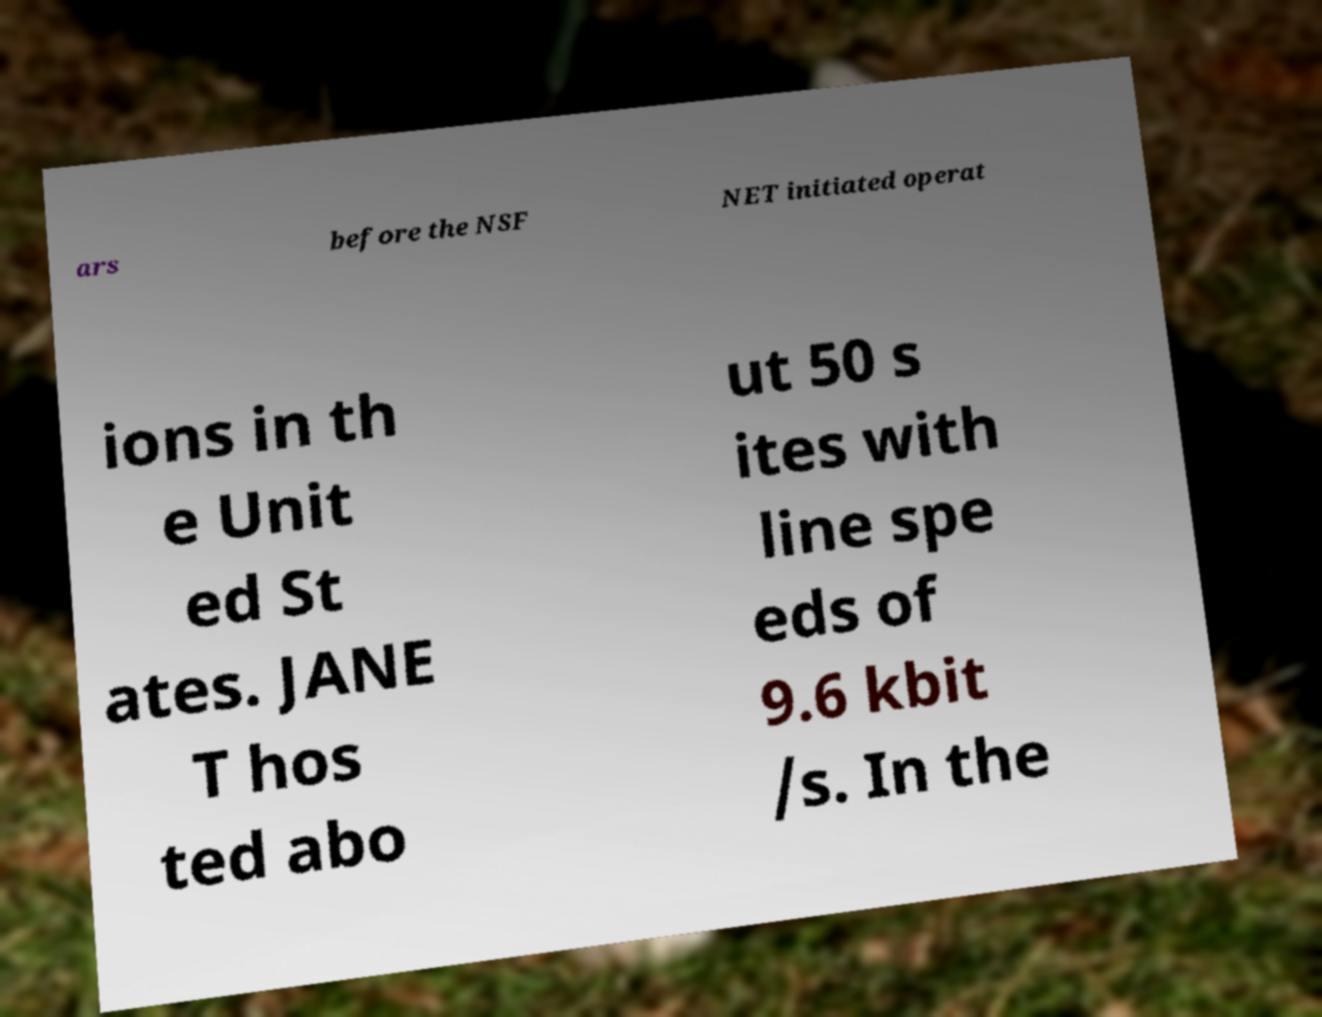I need the written content from this picture converted into text. Can you do that? ars before the NSF NET initiated operat ions in th e Unit ed St ates. JANE T hos ted abo ut 50 s ites with line spe eds of 9.6 kbit /s. In the 